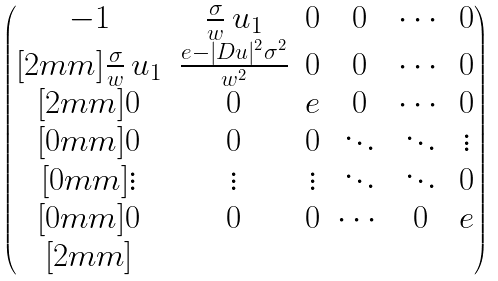Convert formula to latex. <formula><loc_0><loc_0><loc_500><loc_500>\begin{pmatrix} - 1 & \frac { \sigma } { w } \, u _ { 1 } & 0 & 0 & \cdots & 0 \\ [ 2 m m ] \frac { \sigma } { w } \, u _ { 1 } & \frac { e - | D u | ^ { 2 } \sigma ^ { 2 } } { w ^ { 2 } } & 0 & 0 & \cdots & 0 \\ [ 2 m m ] 0 & 0 & e & 0 & \cdots & 0 \\ [ 0 m m ] 0 & 0 & 0 & \ddots & \ddots & \vdots \\ [ 0 m m ] \vdots & \vdots & \vdots & \ddots & \ddots & 0 \\ [ 0 m m ] 0 & 0 & 0 & \cdots & 0 & e \\ [ 2 m m ] \end{pmatrix}</formula> 